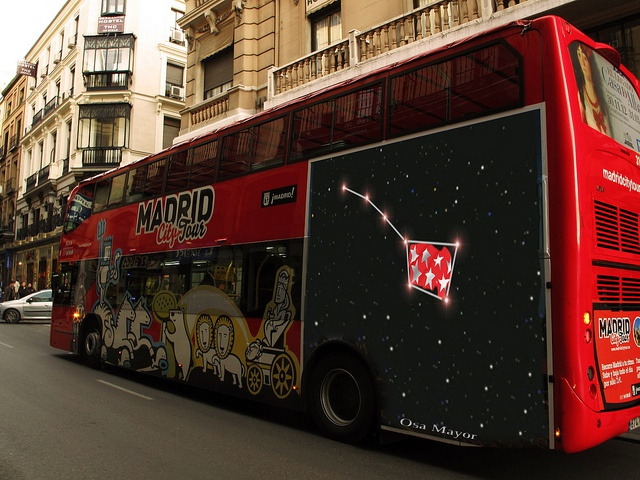Describe the objects in this image and their specific colors. I can see bus in black, white, maroon, red, and gray tones, car in white, gray, black, and ivory tones, people in white, black, maroon, and brown tones, people in white, black, maroon, salmon, and tan tones, and people in white, black, maroon, and brown tones in this image. 